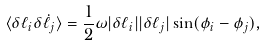Convert formula to latex. <formula><loc_0><loc_0><loc_500><loc_500>\langle \delta \ell _ { i } \delta \dot { \ell } _ { j } \rangle = \frac { 1 } { 2 } \omega | \delta \ell _ { i } | | \delta \ell _ { j } | \sin ( \phi _ { i } - \phi _ { j } ) ,</formula> 